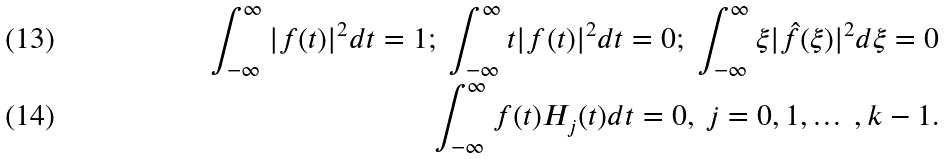<formula> <loc_0><loc_0><loc_500><loc_500>\int _ { - \infty } ^ { \infty } | f ( t ) | ^ { 2 } d t = 1 ; \ \int _ { - \infty } ^ { \infty } t | f ( t ) | ^ { 2 } d t = 0 ; \ \int _ { - \infty } ^ { \infty } \xi | \hat { f } ( \xi ) | ^ { 2 } d \xi = 0 \\ \int _ { - \infty } ^ { \infty } f ( t ) H _ { j } ( t ) d t = 0 , \ j = 0 , 1 , \dots \ , k - 1 .</formula> 